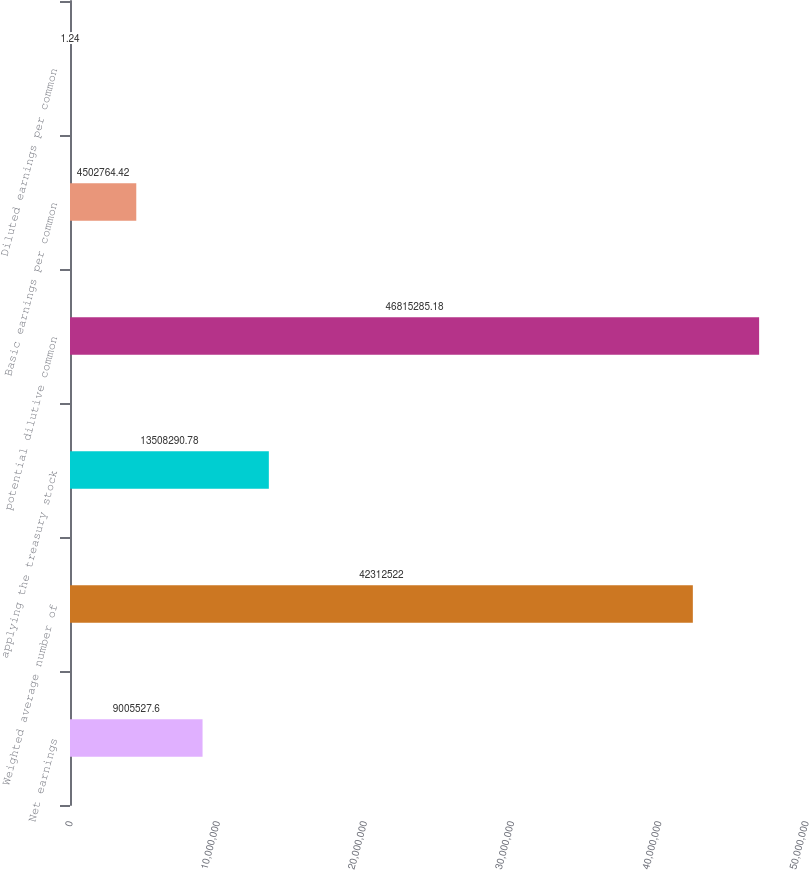Convert chart to OTSL. <chart><loc_0><loc_0><loc_500><loc_500><bar_chart><fcel>Net earnings<fcel>Weighted average number of<fcel>applying the treasury stock<fcel>potential dilutive common<fcel>Basic earnings per common<fcel>Diluted earnings per common<nl><fcel>9.00553e+06<fcel>4.23125e+07<fcel>1.35083e+07<fcel>4.68153e+07<fcel>4.50276e+06<fcel>1.24<nl></chart> 